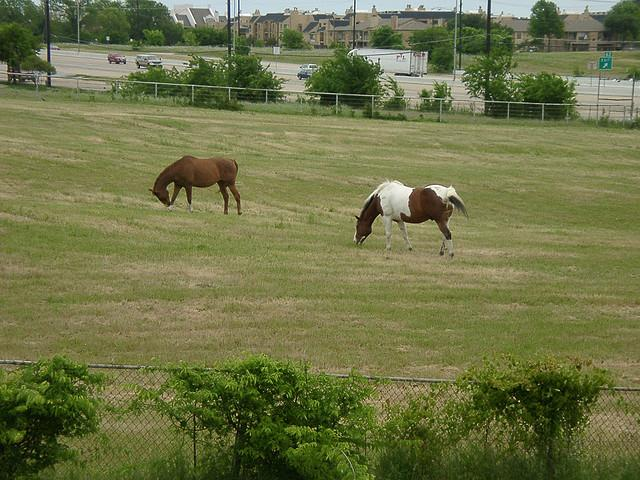What type of animals are present? horses 